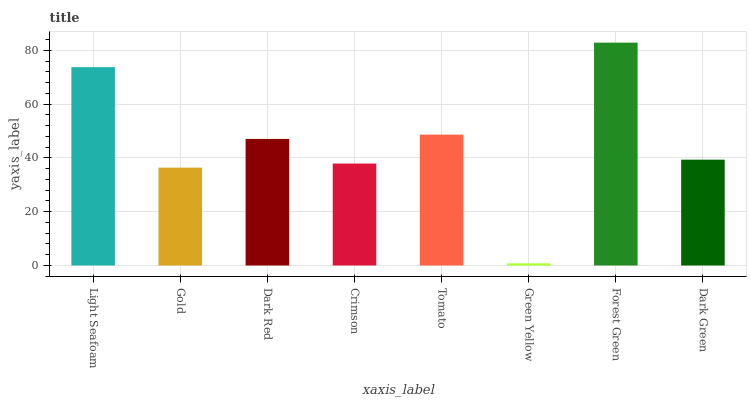Is Gold the minimum?
Answer yes or no. No. Is Gold the maximum?
Answer yes or no. No. Is Light Seafoam greater than Gold?
Answer yes or no. Yes. Is Gold less than Light Seafoam?
Answer yes or no. Yes. Is Gold greater than Light Seafoam?
Answer yes or no. No. Is Light Seafoam less than Gold?
Answer yes or no. No. Is Dark Red the high median?
Answer yes or no. Yes. Is Dark Green the low median?
Answer yes or no. Yes. Is Light Seafoam the high median?
Answer yes or no. No. Is Green Yellow the low median?
Answer yes or no. No. 